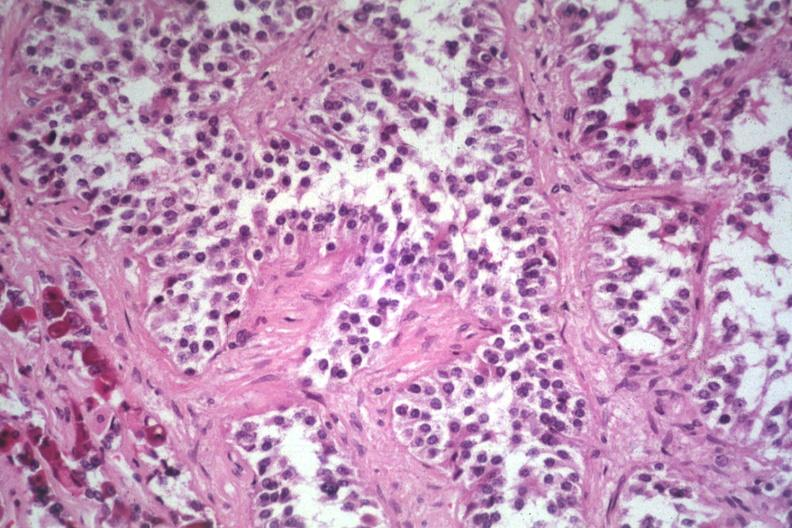does this image show papillary lesion unusual?
Answer the question using a single word or phrase. Yes 